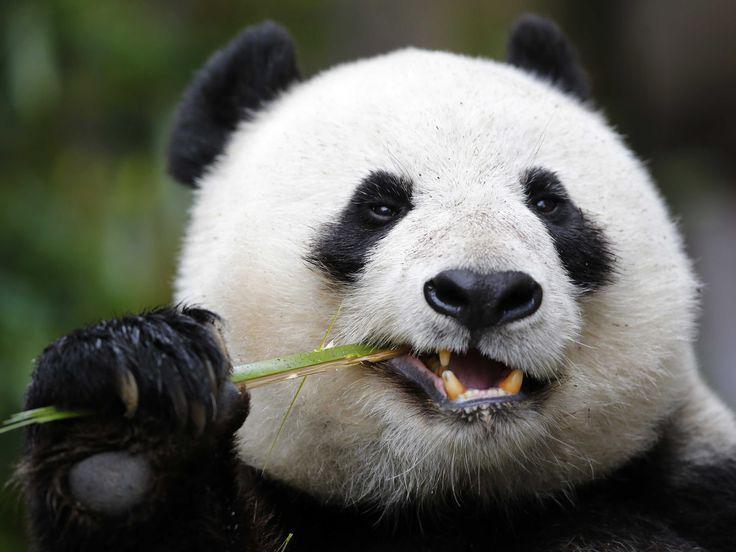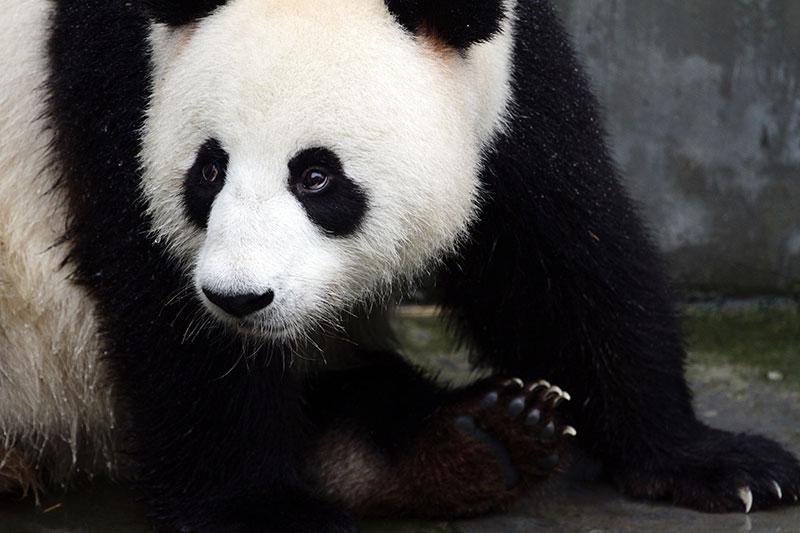The first image is the image on the left, the second image is the image on the right. Analyze the images presented: Is the assertion "In one of the photos, a panda is eating a bamboo shoot" valid? Answer yes or no. Yes. The first image is the image on the left, the second image is the image on the right. Examine the images to the left and right. Is the description "There are more panda bears in the left image than in the right." accurate? Answer yes or no. No. 